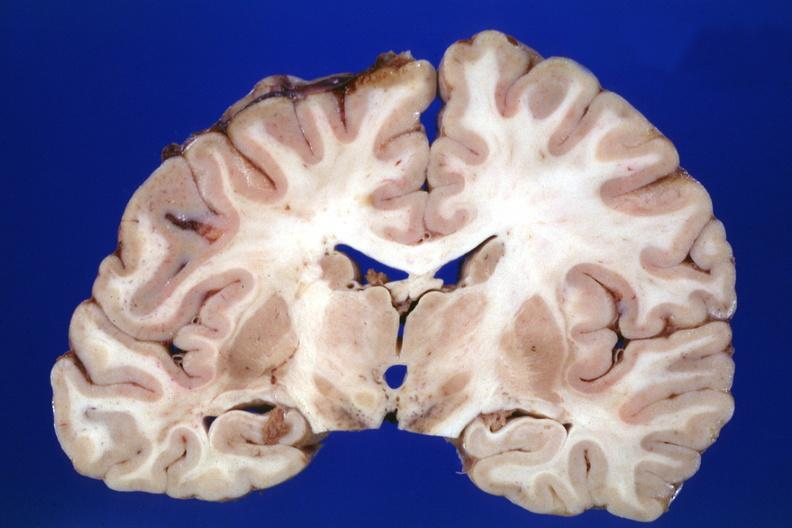what was in the pons?
Answer the question using a single word or phrase. The lesion 